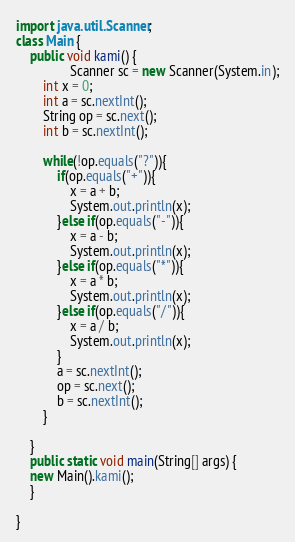Convert code to text. <code><loc_0><loc_0><loc_500><loc_500><_Java_>import java.util.Scanner;
class Main {
    public void kami() {
        		Scanner sc = new Scanner(System.in);
		int x = 0;
		int a = sc.nextInt();
		String op = sc.next();
		int b = sc.nextInt();
		
		while(!op.equals("?")){
			if(op.equals("+")){
				x = a + b;
				System.out.println(x);
			}else if(op.equals("-")){
				x = a - b;
				System.out.println(x);
			}else if(op.equals("*")){
				x = a * b;
				System.out.println(x);
			}else if(op.equals("/")){
				x = a / b;
				System.out.println(x);
			}
			a = sc.nextInt();
			op = sc.next();
			b = sc.nextInt();
		}

    }
	public static void main(String[] args) {
    new Main().kami();
	}

}</code> 